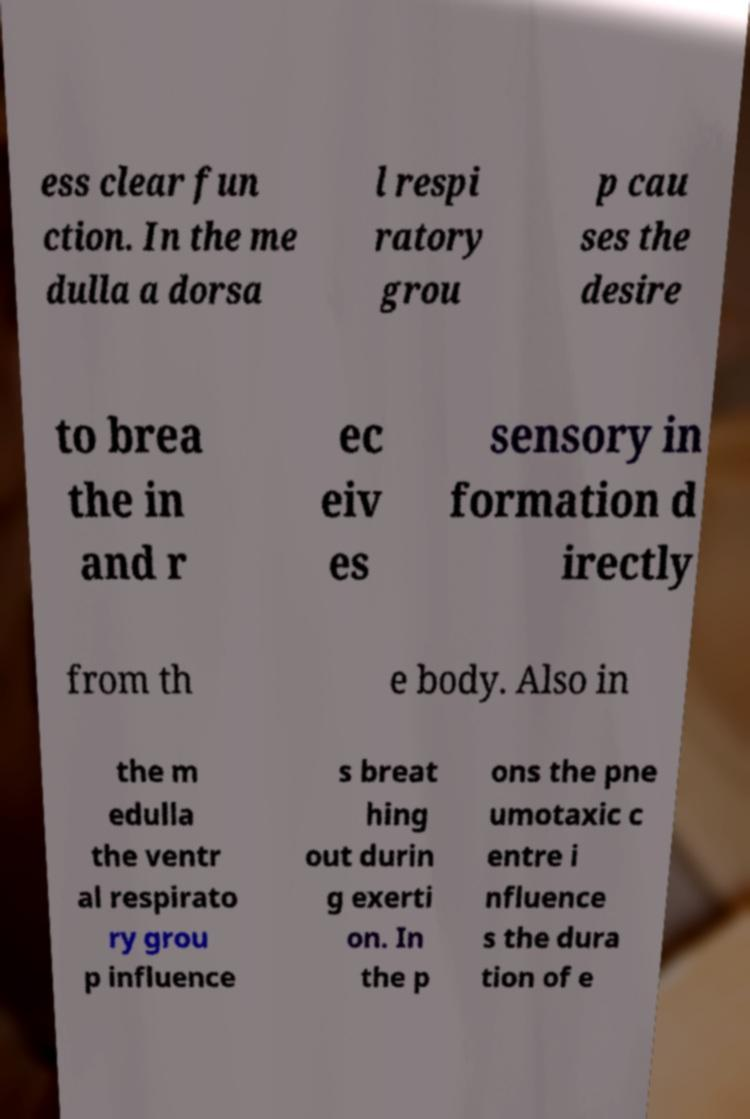Please read and relay the text visible in this image. What does it say? ess clear fun ction. In the me dulla a dorsa l respi ratory grou p cau ses the desire to brea the in and r ec eiv es sensory in formation d irectly from th e body. Also in the m edulla the ventr al respirato ry grou p influence s breat hing out durin g exerti on. In the p ons the pne umotaxic c entre i nfluence s the dura tion of e 